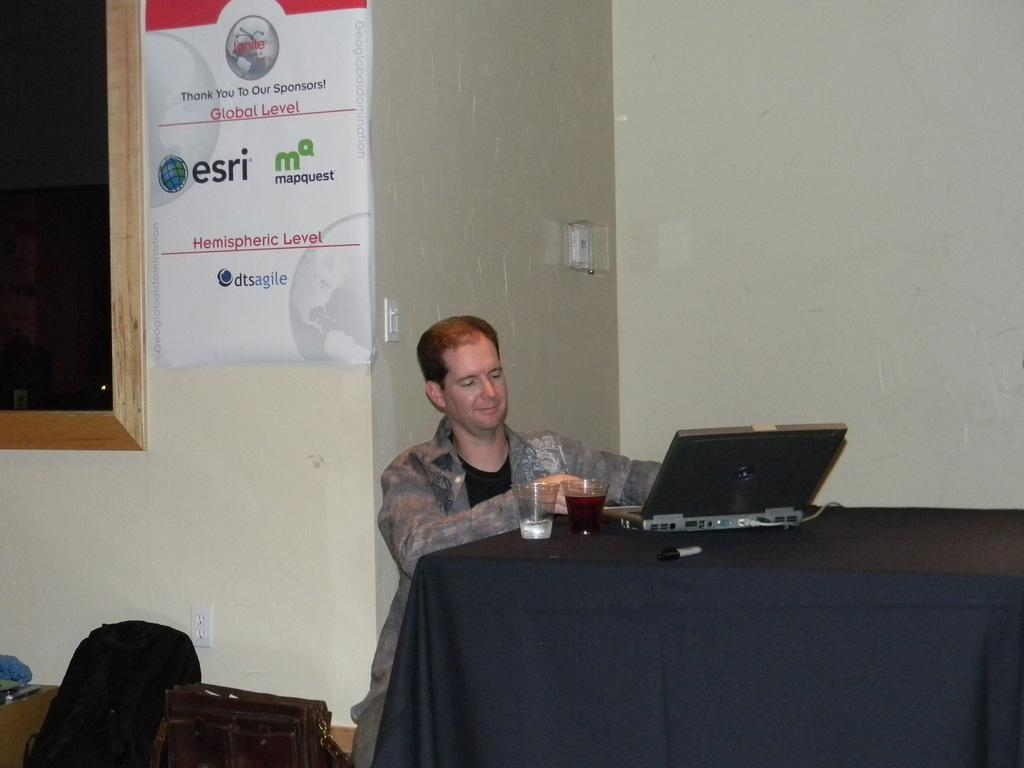What is the man in the image doing? The man is seated on a chair in the image. What is placed in front of the man? There are glasses in front of the man. What electronic device can be seen on a table in the image? There is a laptop on a table in the image. What can be seen in the background of the image? There is a hoarding and baggage in the background of the image. Can you see a turkey swimming in the stream in the image? There is no stream or turkey present in the image. 